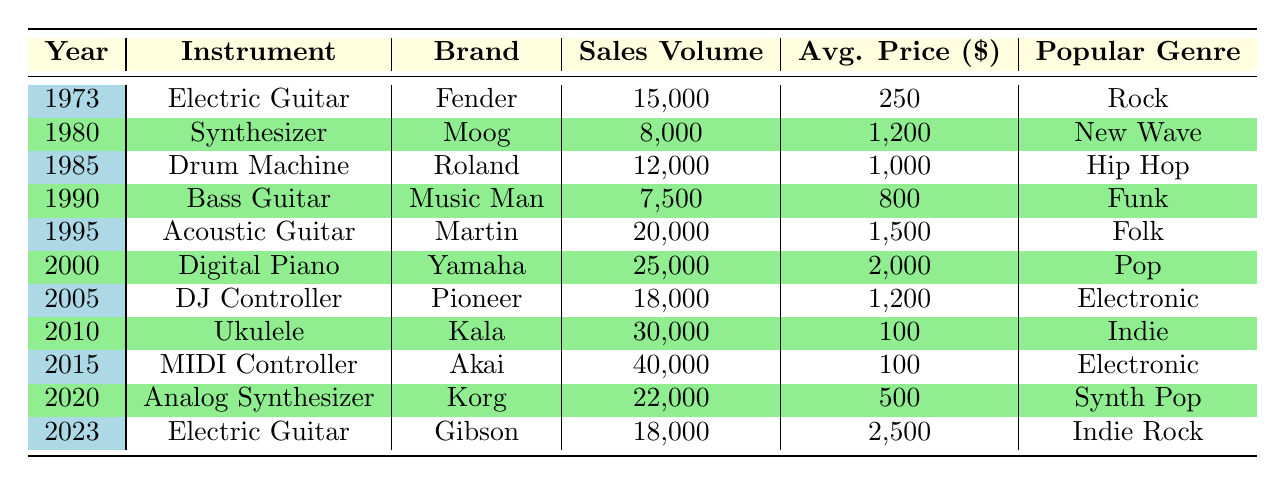What instrument had the highest sales volume in the year 2015? In 2015, the sales volume for the MIDI Controller by Akai was 40,000, which is the highest for that year according to the table. No other instrument listed in 2015 comes close to this figure.
Answer: MIDI Controller by Akai Which brand sold the most electric guitars according to the table? The table shows two electric guitars: Fender in 1973 with 15,000 units sold and Gibson in 2023 with 18,000 units sold. Therefore, Gibson sold the most electric guitars.
Answer: Gibson What was the average price of instruments sold in 2000? In 2000, the Digital Piano by Yamaha was sold at an average price of 2,000 dollars. This is a straightforward retrieval from the table.
Answer: 2000 Which instrument had the lowest average price over the entire period? Checking the table, the Ukulele by Kala in 2010 was sold at an average price of 100 dollars, which is the lowest when comparing all instruments listed in the table.
Answer: Ukulele by Kala Was the sales volume of the Drum Machine higher than that of the Bass Guitar? The Drum Machine sold 12,000 units in 1985, while the Bass Guitar sold 7,500 units in 1990. Since 12,000 is greater than 7,500, the statement is true.
Answer: Yes How many total sales were made for electric guitars across all years in the table? There are electric guitars listed for 1973 with 15,000 units and for 2023 with 18,000 units, summing these gives 15,000 + 18,000 = 33,000 units sold in total.
Answer: 33,000 Which year had the most sales volume for any instrument, and what was it? The highest sales volume for an instrument per the table was 40,000 units in 2015 for the MIDI Controller by Akai. This requires looking closely at the sales volumes across all years listed to find the highest number.
Answer: 2015, 40,000 units What was the sales volume for the Acoustic Guitar in 1995? According to the table, the sales volume for the Acoustic Guitar by Martin was listed as 20,000 units in 1995, which can be directly referenced from the year.
Answer: 20,000 units 